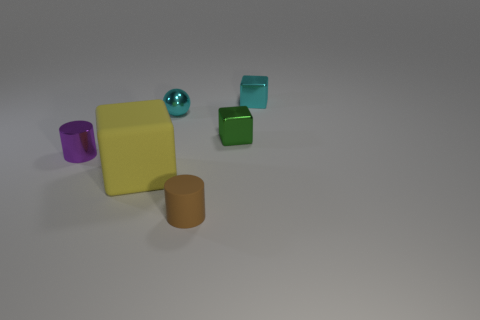Considering the texture and light, what can you tell me about the surface the objects are on? The objects are placed on a smooth and even surface that reflects light subtly, suggesting it might be made of a matte material. The soft shadows cast by the objects indicate the presence of a diffuse light source overhead. 